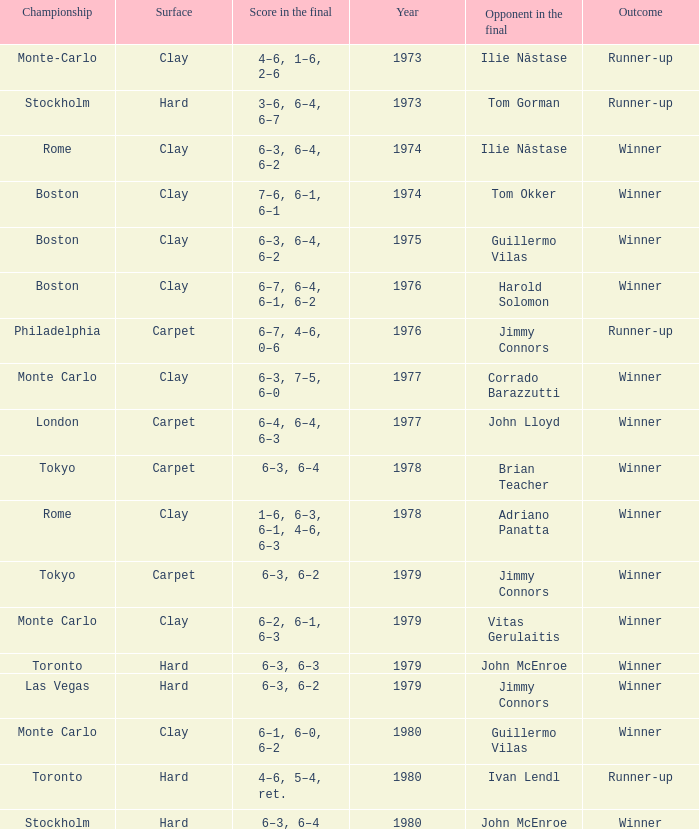Name the year for clay for boston and guillermo vilas 1975.0. Parse the full table. {'header': ['Championship', 'Surface', 'Score in the final', 'Year', 'Opponent in the final', 'Outcome'], 'rows': [['Monte-Carlo', 'Clay', '4–6, 1–6, 2–6', '1973', 'Ilie Năstase', 'Runner-up'], ['Stockholm', 'Hard', '3–6, 6–4, 6–7', '1973', 'Tom Gorman', 'Runner-up'], ['Rome', 'Clay', '6–3, 6–4, 6–2', '1974', 'Ilie Năstase', 'Winner'], ['Boston', 'Clay', '7–6, 6–1, 6–1', '1974', 'Tom Okker', 'Winner'], ['Boston', 'Clay', '6–3, 6–4, 6–2', '1975', 'Guillermo Vilas', 'Winner'], ['Boston', 'Clay', '6–7, 6–4, 6–1, 6–2', '1976', 'Harold Solomon', 'Winner'], ['Philadelphia', 'Carpet', '6–7, 4–6, 0–6', '1976', 'Jimmy Connors', 'Runner-up'], ['Monte Carlo', 'Clay', '6–3, 7–5, 6–0', '1977', 'Corrado Barazzutti', 'Winner'], ['London', 'Carpet', '6–4, 6–4, 6–3', '1977', 'John Lloyd', 'Winner'], ['Tokyo', 'Carpet', '6–3, 6–4', '1978', 'Brian Teacher', 'Winner'], ['Rome', 'Clay', '1–6, 6–3, 6–1, 4–6, 6–3', '1978', 'Adriano Panatta', 'Winner'], ['Tokyo', 'Carpet', '6–3, 6–2', '1979', 'Jimmy Connors', 'Winner'], ['Monte Carlo', 'Clay', '6–2, 6–1, 6–3', '1979', 'Vitas Gerulaitis', 'Winner'], ['Toronto', 'Hard', '6–3, 6–3', '1979', 'John McEnroe', 'Winner'], ['Las Vegas', 'Hard', '6–3, 6–2', '1979', 'Jimmy Connors', 'Winner'], ['Monte Carlo', 'Clay', '6–1, 6–0, 6–2', '1980', 'Guillermo Vilas', 'Winner'], ['Toronto', 'Hard', '4–6, 5–4, ret.', '1980', 'Ivan Lendl', 'Runner-up'], ['Stockholm', 'Hard', '6–3, 6–4', '1980', 'John McEnroe', 'Winner']]} 